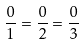Convert formula to latex. <formula><loc_0><loc_0><loc_500><loc_500>\frac { 0 } { 1 } = \frac { 0 } { 2 } = \frac { 0 } { 3 }</formula> 